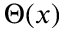<formula> <loc_0><loc_0><loc_500><loc_500>\Theta ( x )</formula> 